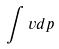<formula> <loc_0><loc_0><loc_500><loc_500>\int v d p</formula> 